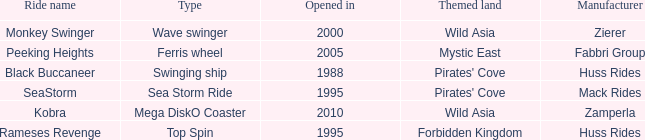What type ride is Wild Asia that opened in 2000? Wave swinger. 